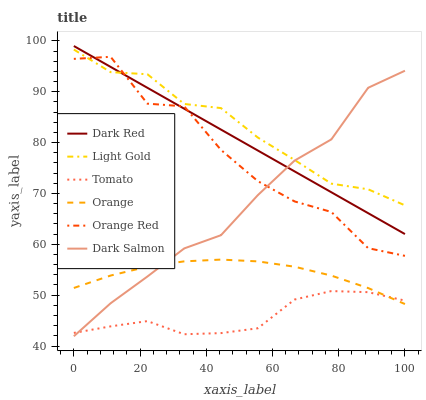Does Tomato have the minimum area under the curve?
Answer yes or no. Yes. Does Light Gold have the maximum area under the curve?
Answer yes or no. Yes. Does Dark Red have the minimum area under the curve?
Answer yes or no. No. Does Dark Red have the maximum area under the curve?
Answer yes or no. No. Is Dark Red the smoothest?
Answer yes or no. Yes. Is Orange Red the roughest?
Answer yes or no. Yes. Is Dark Salmon the smoothest?
Answer yes or no. No. Is Dark Salmon the roughest?
Answer yes or no. No. Does Dark Salmon have the lowest value?
Answer yes or no. Yes. Does Dark Red have the lowest value?
Answer yes or no. No. Does Dark Red have the highest value?
Answer yes or no. Yes. Does Dark Salmon have the highest value?
Answer yes or no. No. Is Tomato less than Dark Red?
Answer yes or no. Yes. Is Dark Red greater than Tomato?
Answer yes or no. Yes. Does Dark Red intersect Dark Salmon?
Answer yes or no. Yes. Is Dark Red less than Dark Salmon?
Answer yes or no. No. Is Dark Red greater than Dark Salmon?
Answer yes or no. No. Does Tomato intersect Dark Red?
Answer yes or no. No. 